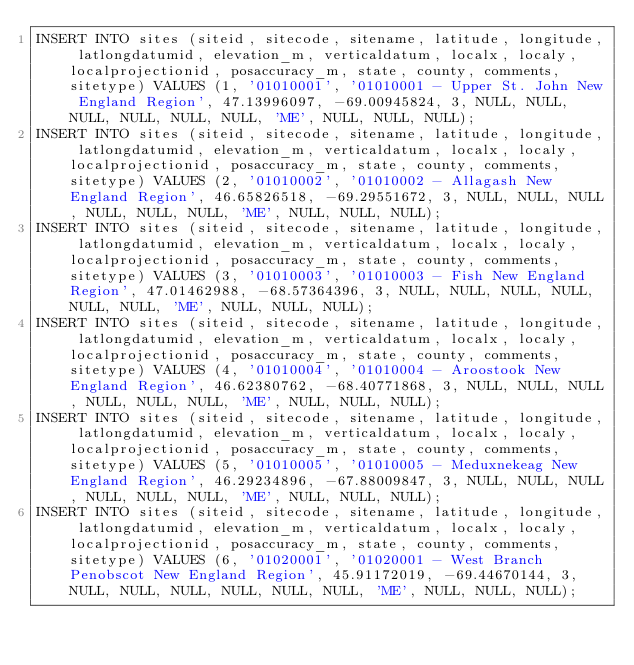<code> <loc_0><loc_0><loc_500><loc_500><_SQL_>INSERT INTO sites (siteid, sitecode, sitename, latitude, longitude, latlongdatumid, elevation_m, verticaldatum, localx, localy, localprojectionid, posaccuracy_m, state, county, comments, sitetype) VALUES (1, '01010001', '01010001 - Upper St. John New England Region', 47.13996097, -69.00945824, 3, NULL, NULL, NULL, NULL, NULL, NULL, 'ME', NULL, NULL, NULL);
INSERT INTO sites (siteid, sitecode, sitename, latitude, longitude, latlongdatumid, elevation_m, verticaldatum, localx, localy, localprojectionid, posaccuracy_m, state, county, comments, sitetype) VALUES (2, '01010002', '01010002 - Allagash New England Region', 46.65826518, -69.29551672, 3, NULL, NULL, NULL, NULL, NULL, NULL, 'ME', NULL, NULL, NULL);
INSERT INTO sites (siteid, sitecode, sitename, latitude, longitude, latlongdatumid, elevation_m, verticaldatum, localx, localy, localprojectionid, posaccuracy_m, state, county, comments, sitetype) VALUES (3, '01010003', '01010003 - Fish New England Region', 47.01462988, -68.57364396, 3, NULL, NULL, NULL, NULL, NULL, NULL, 'ME', NULL, NULL, NULL);
INSERT INTO sites (siteid, sitecode, sitename, latitude, longitude, latlongdatumid, elevation_m, verticaldatum, localx, localy, localprojectionid, posaccuracy_m, state, county, comments, sitetype) VALUES (4, '01010004', '01010004 - Aroostook New England Region', 46.62380762, -68.40771868, 3, NULL, NULL, NULL, NULL, NULL, NULL, 'ME', NULL, NULL, NULL);
INSERT INTO sites (siteid, sitecode, sitename, latitude, longitude, latlongdatumid, elevation_m, verticaldatum, localx, localy, localprojectionid, posaccuracy_m, state, county, comments, sitetype) VALUES (5, '01010005', '01010005 - Meduxnekeag New England Region', 46.29234896, -67.88009847, 3, NULL, NULL, NULL, NULL, NULL, NULL, 'ME', NULL, NULL, NULL);
INSERT INTO sites (siteid, sitecode, sitename, latitude, longitude, latlongdatumid, elevation_m, verticaldatum, localx, localy, localprojectionid, posaccuracy_m, state, county, comments, sitetype) VALUES (6, '01020001', '01020001 - West Branch Penobscot New England Region', 45.91172019, -69.44670144, 3, NULL, NULL, NULL, NULL, NULL, NULL, 'ME', NULL, NULL, NULL);</code> 